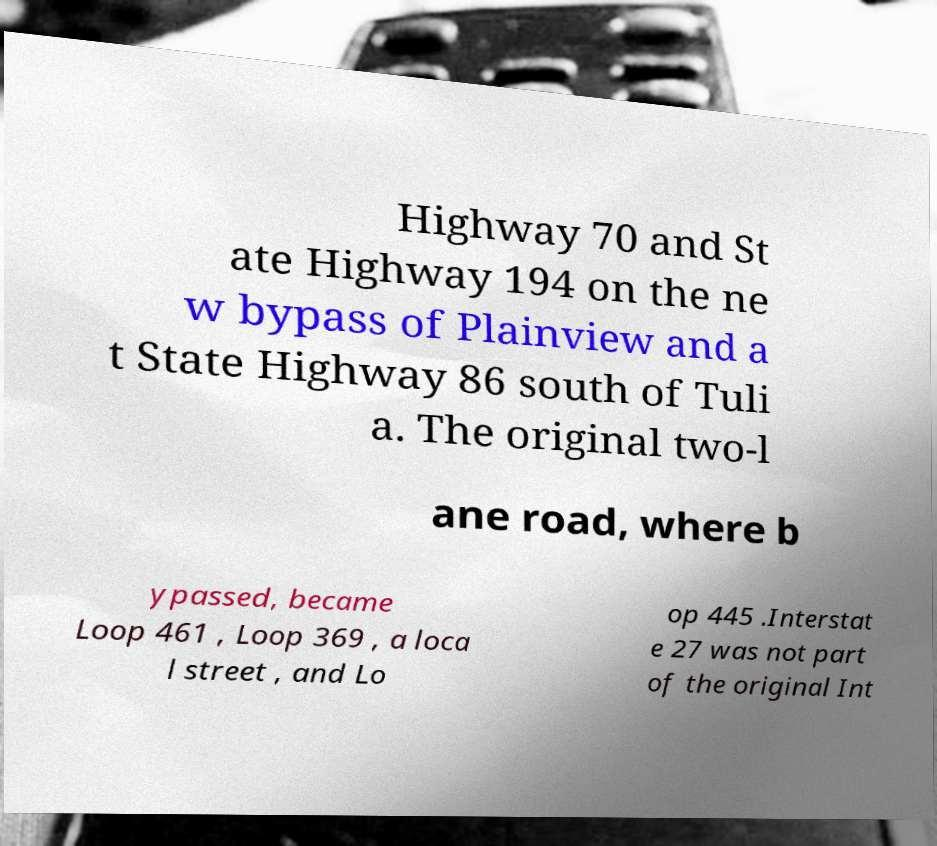Could you assist in decoding the text presented in this image and type it out clearly? Highway 70 and St ate Highway 194 on the ne w bypass of Plainview and a t State Highway 86 south of Tuli a. The original two-l ane road, where b ypassed, became Loop 461 , Loop 369 , a loca l street , and Lo op 445 .Interstat e 27 was not part of the original Int 